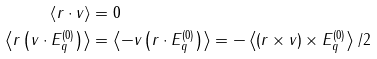<formula> <loc_0><loc_0><loc_500><loc_500>\left \langle r \cdot v \right \rangle & = 0 \\ \left \langle r \left ( v \cdot E _ { q } ^ { ( 0 ) } \right ) \right \rangle & = \left \langle - v \left ( r \cdot E _ { q } ^ { ( 0 ) } \right ) \right \rangle = - \left \langle \left ( r \times v \right ) \times E _ { q } ^ { ( 0 ) } \right \rangle / 2</formula> 